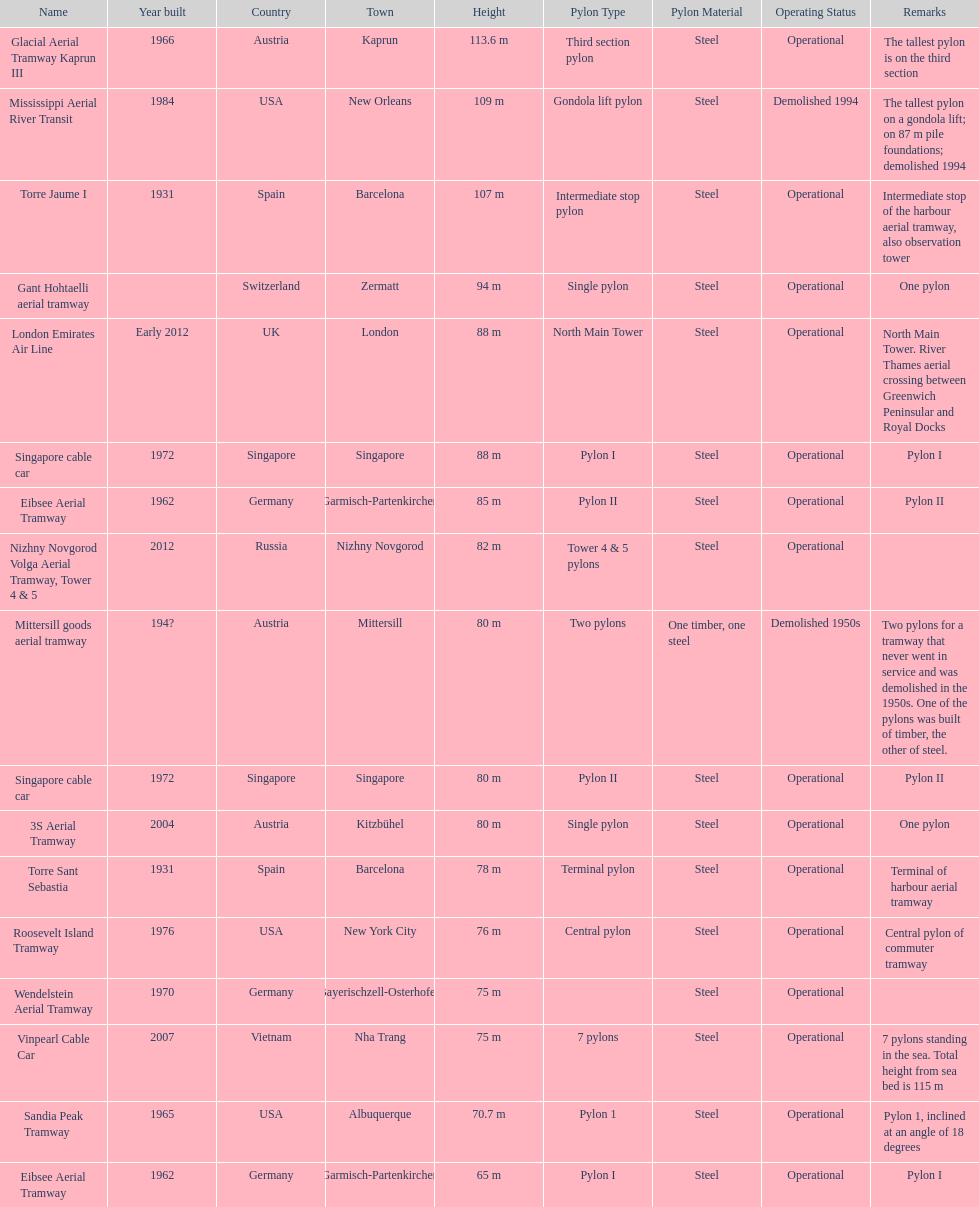How many pylons are at least 80 meters tall? 11. 